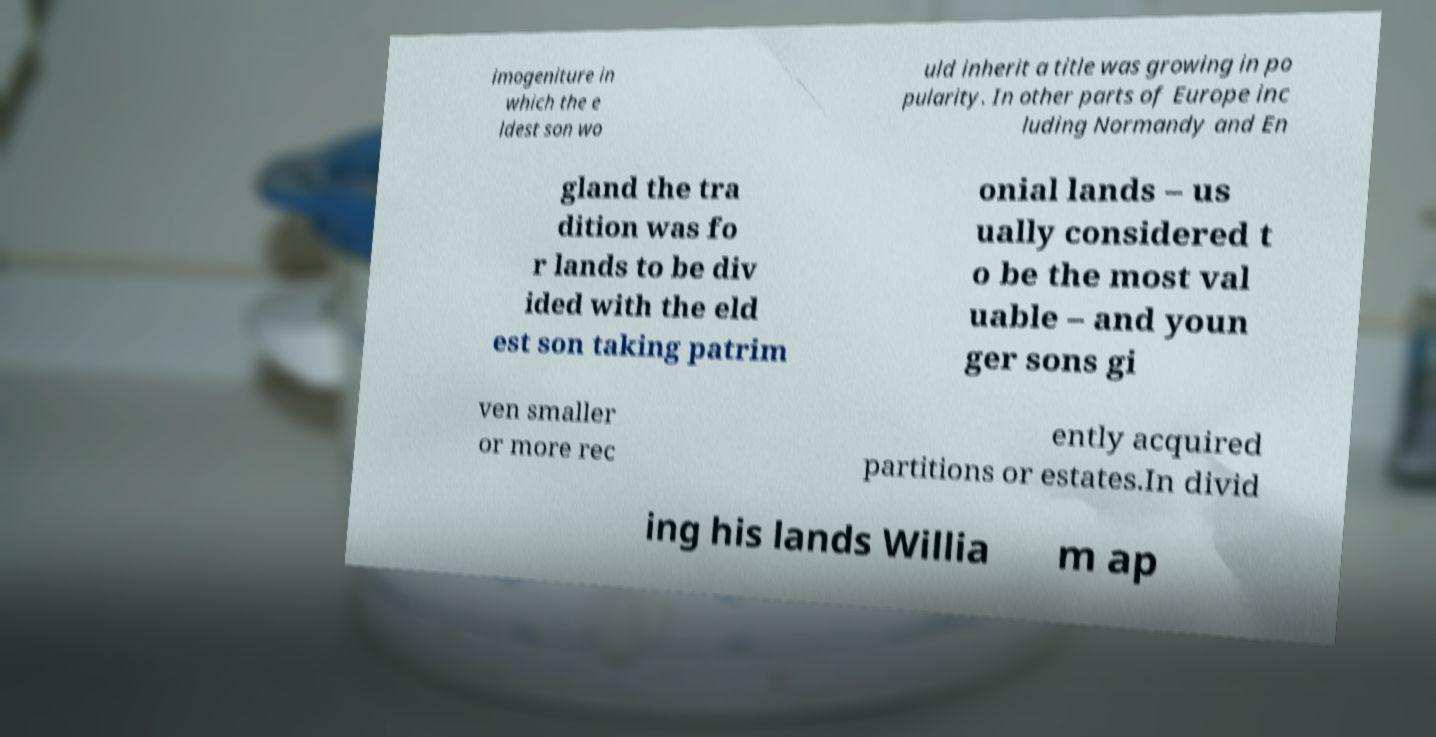Could you extract and type out the text from this image? imogeniture in which the e ldest son wo uld inherit a title was growing in po pularity. In other parts of Europe inc luding Normandy and En gland the tra dition was fo r lands to be div ided with the eld est son taking patrim onial lands – us ually considered t o be the most val uable – and youn ger sons gi ven smaller or more rec ently acquired partitions or estates.In divid ing his lands Willia m ap 